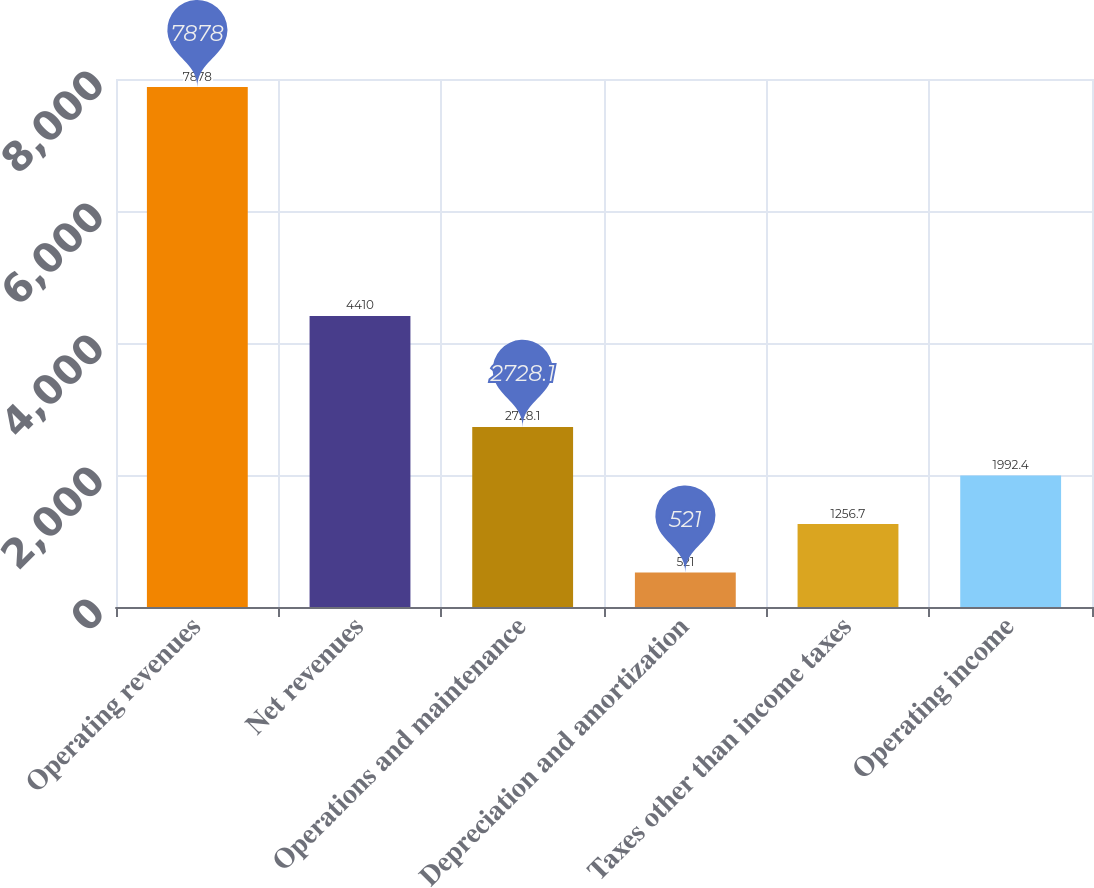Convert chart to OTSL. <chart><loc_0><loc_0><loc_500><loc_500><bar_chart><fcel>Operating revenues<fcel>Net revenues<fcel>Operations and maintenance<fcel>Depreciation and amortization<fcel>Taxes other than income taxes<fcel>Operating income<nl><fcel>7878<fcel>4410<fcel>2728.1<fcel>521<fcel>1256.7<fcel>1992.4<nl></chart> 